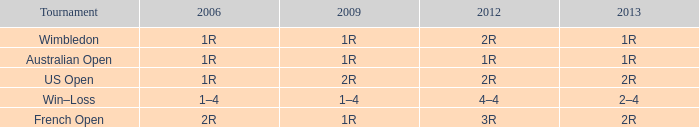Parse the full table. {'header': ['Tournament', '2006', '2009', '2012', '2013'], 'rows': [['Wimbledon', '1R', '1R', '2R', '1R'], ['Australian Open', '1R', '1R', '1R', '1R'], ['US Open', '1R', '2R', '2R', '2R'], ['Win–Loss', '1–4', '1–4', '4–4', '2–4'], ['French Open', '2R', '1R', '3R', '2R']]} What is the 2006 when the 2013 is 1r, and the 2012 is 1r? 1R. 